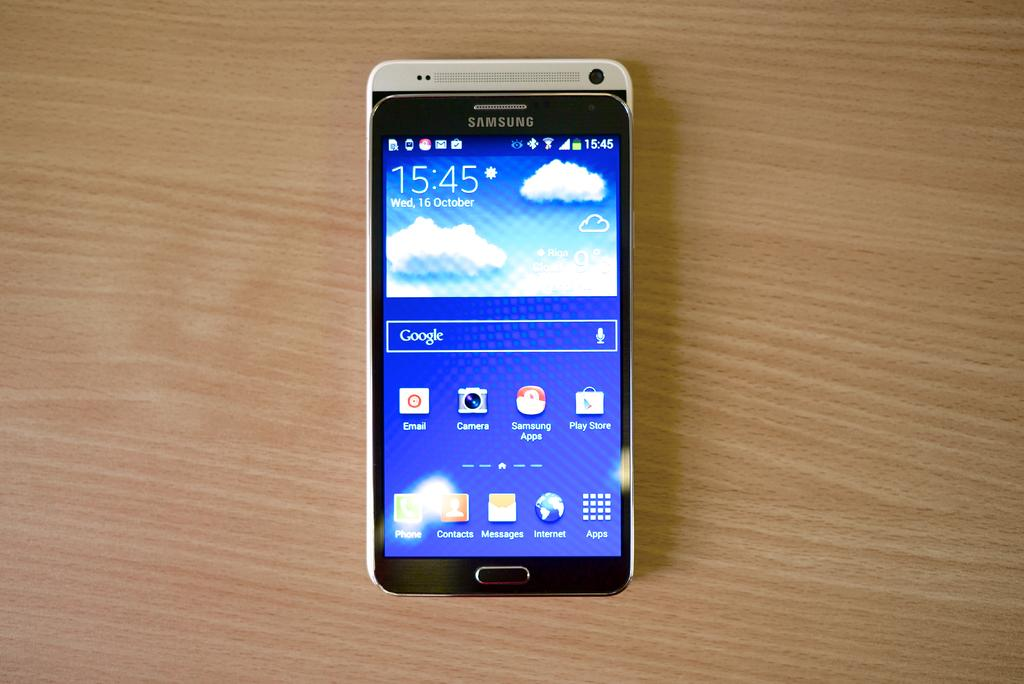<image>
Give a short and clear explanation of the subsequent image. A Samsung phone shows that it is 15:45 on Wednesday October 16th. 